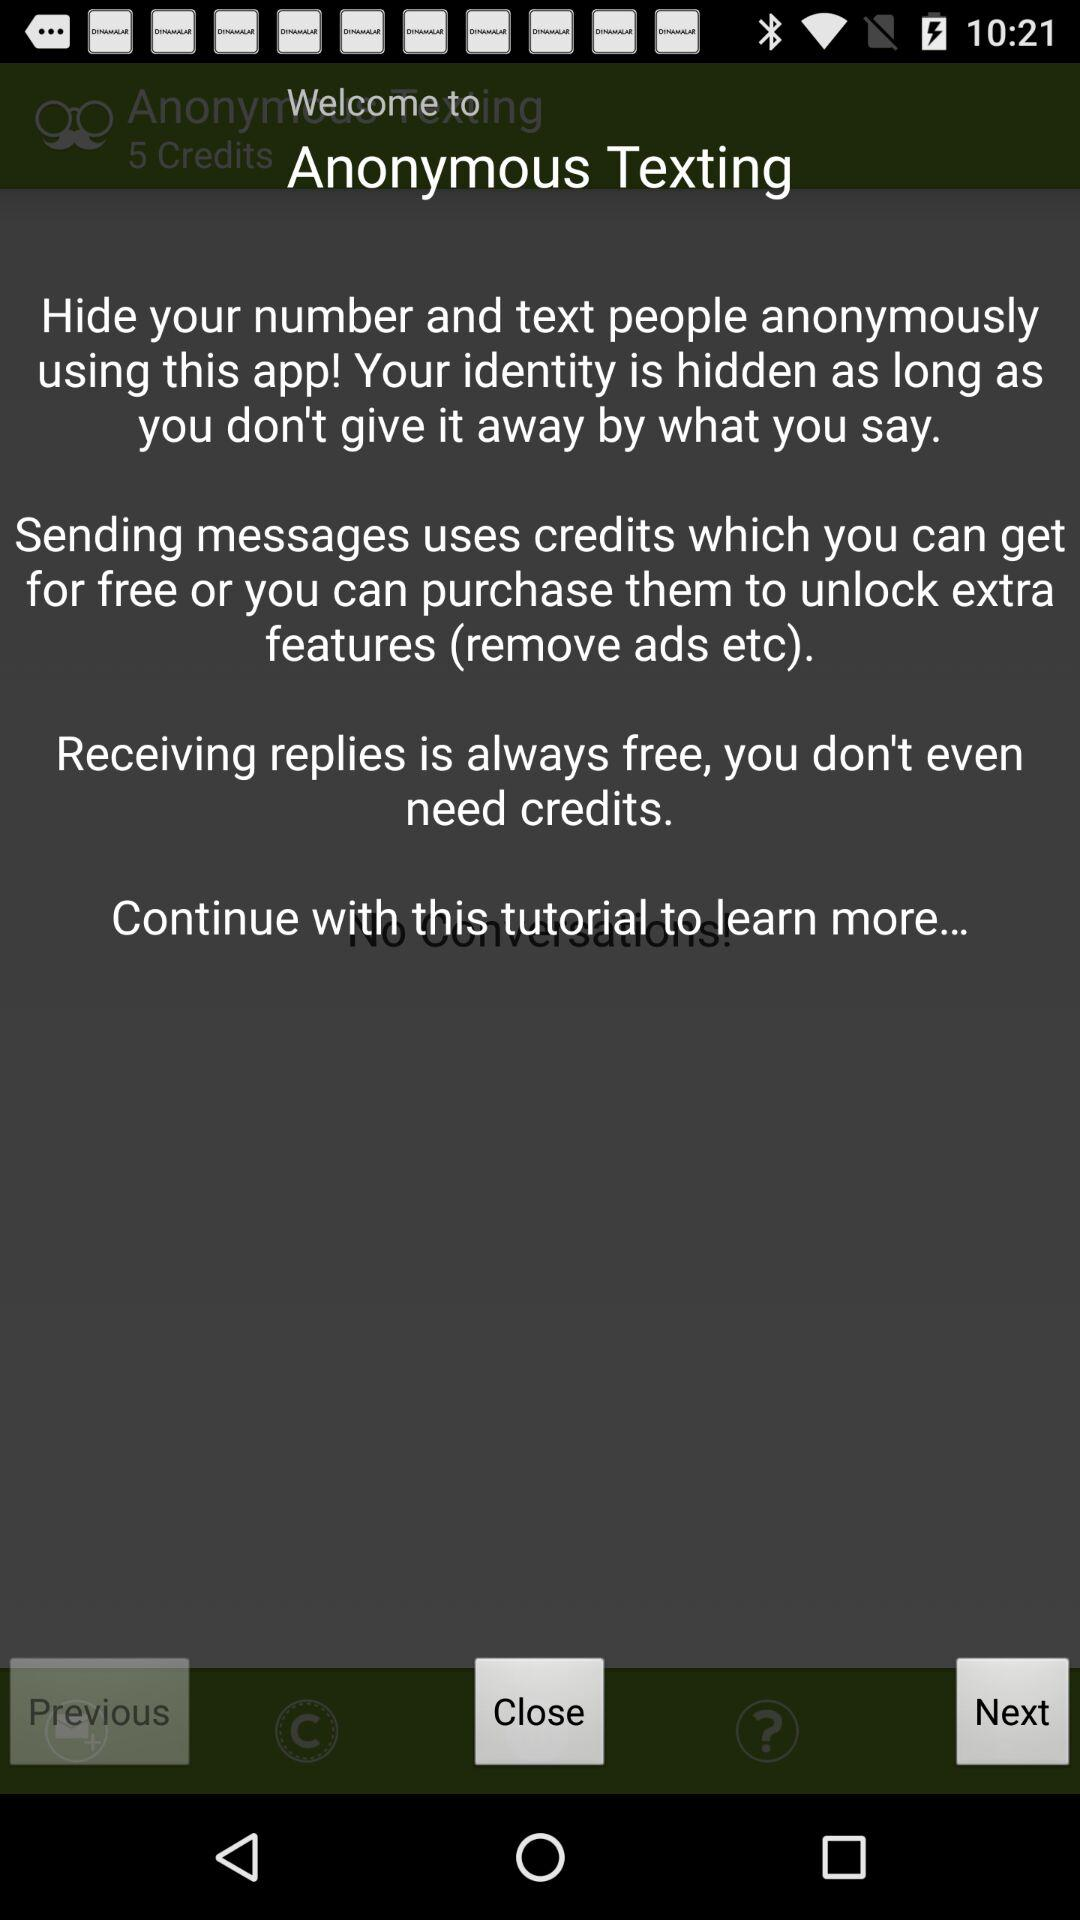How many credits do I currently have?
Answer the question using a single word or phrase. 5 